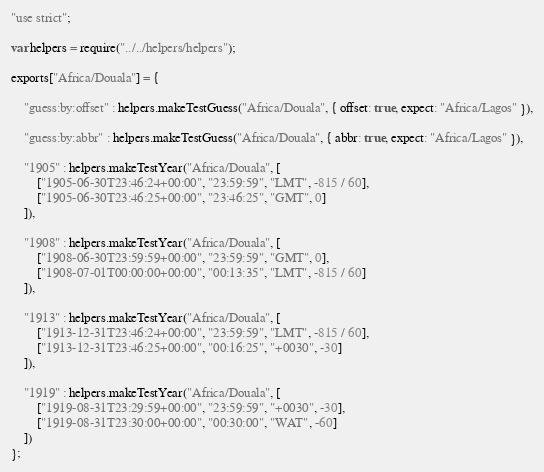<code> <loc_0><loc_0><loc_500><loc_500><_JavaScript_>"use strict";

var helpers = require("../../helpers/helpers");

exports["Africa/Douala"] = {

	"guess:by:offset" : helpers.makeTestGuess("Africa/Douala", { offset: true, expect: "Africa/Lagos" }),

	"guess:by:abbr" : helpers.makeTestGuess("Africa/Douala", { abbr: true, expect: "Africa/Lagos" }),

	"1905" : helpers.makeTestYear("Africa/Douala", [
		["1905-06-30T23:46:24+00:00", "23:59:59", "LMT", -815 / 60],
		["1905-06-30T23:46:25+00:00", "23:46:25", "GMT", 0]
	]),

	"1908" : helpers.makeTestYear("Africa/Douala", [
		["1908-06-30T23:59:59+00:00", "23:59:59", "GMT", 0],
		["1908-07-01T00:00:00+00:00", "00:13:35", "LMT", -815 / 60]
	]),

	"1913" : helpers.makeTestYear("Africa/Douala", [
		["1913-12-31T23:46:24+00:00", "23:59:59", "LMT", -815 / 60],
		["1913-12-31T23:46:25+00:00", "00:16:25", "+0030", -30]
	]),

	"1919" : helpers.makeTestYear("Africa/Douala", [
		["1919-08-31T23:29:59+00:00", "23:59:59", "+0030", -30],
		["1919-08-31T23:30:00+00:00", "00:30:00", "WAT", -60]
	])
};</code> 